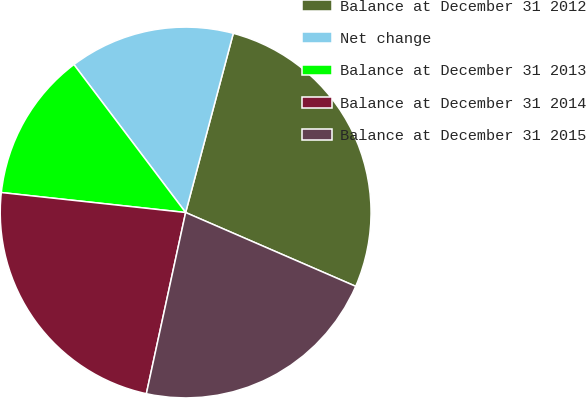Convert chart to OTSL. <chart><loc_0><loc_0><loc_500><loc_500><pie_chart><fcel>Balance at December 31 2012<fcel>Net change<fcel>Balance at December 31 2013<fcel>Balance at December 31 2014<fcel>Balance at December 31 2015<nl><fcel>27.38%<fcel>14.43%<fcel>12.99%<fcel>23.32%<fcel>21.88%<nl></chart> 